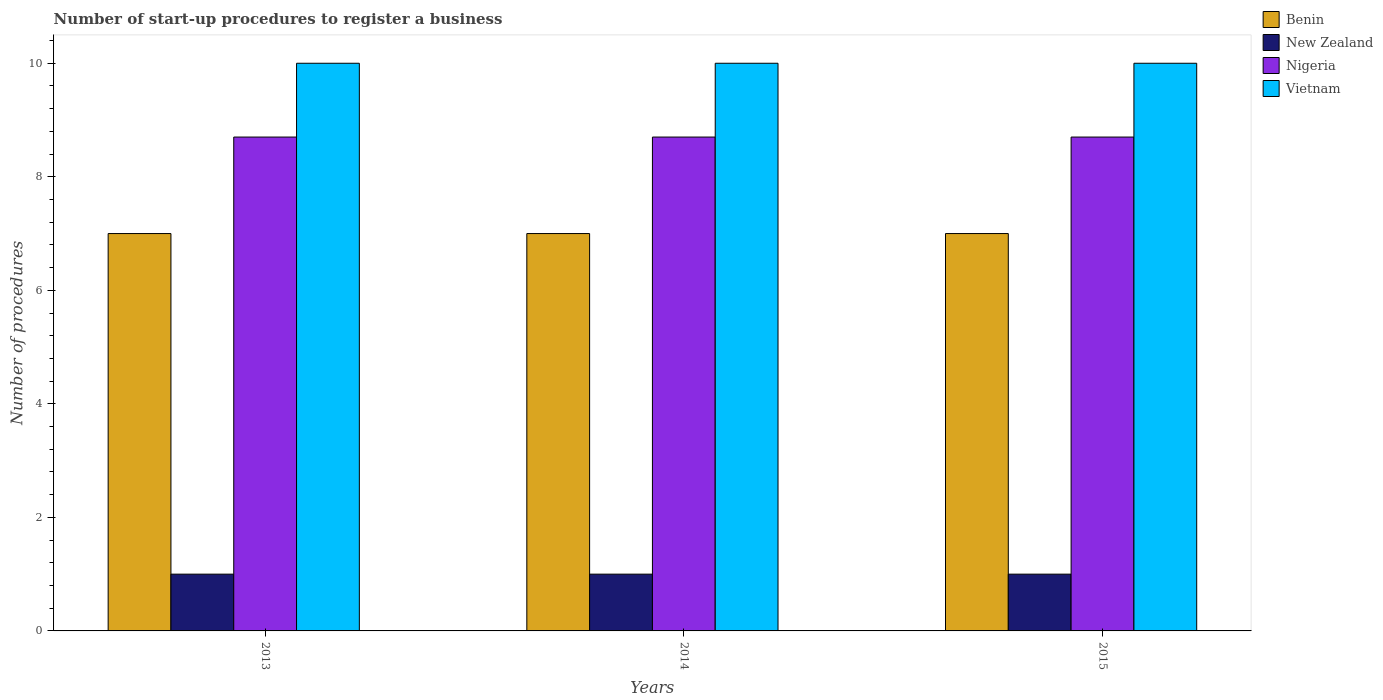How many different coloured bars are there?
Keep it short and to the point. 4. How many groups of bars are there?
Your response must be concise. 3. Are the number of bars per tick equal to the number of legend labels?
Make the answer very short. Yes. Are the number of bars on each tick of the X-axis equal?
Ensure brevity in your answer.  Yes. How many bars are there on the 1st tick from the right?
Keep it short and to the point. 4. What is the number of procedures required to register a business in Vietnam in 2015?
Your response must be concise. 10. Across all years, what is the maximum number of procedures required to register a business in Benin?
Offer a very short reply. 7. Across all years, what is the minimum number of procedures required to register a business in Nigeria?
Give a very brief answer. 8.7. What is the total number of procedures required to register a business in Benin in the graph?
Your response must be concise. 21. What is the difference between the number of procedures required to register a business in New Zealand in 2014 and the number of procedures required to register a business in Vietnam in 2013?
Offer a very short reply. -9. What is the average number of procedures required to register a business in Nigeria per year?
Make the answer very short. 8.7. In the year 2014, what is the difference between the number of procedures required to register a business in Vietnam and number of procedures required to register a business in Nigeria?
Offer a very short reply. 1.3. What is the ratio of the number of procedures required to register a business in Benin in 2013 to that in 2014?
Keep it short and to the point. 1. Is the number of procedures required to register a business in Benin in 2013 less than that in 2015?
Your answer should be very brief. No. Is the difference between the number of procedures required to register a business in Vietnam in 2013 and 2015 greater than the difference between the number of procedures required to register a business in Nigeria in 2013 and 2015?
Provide a succinct answer. No. What is the difference between the highest and the second highest number of procedures required to register a business in Benin?
Ensure brevity in your answer.  0. What is the difference between the highest and the lowest number of procedures required to register a business in New Zealand?
Keep it short and to the point. 0. Is it the case that in every year, the sum of the number of procedures required to register a business in New Zealand and number of procedures required to register a business in Nigeria is greater than the sum of number of procedures required to register a business in Benin and number of procedures required to register a business in Vietnam?
Make the answer very short. No. What does the 3rd bar from the left in 2013 represents?
Provide a succinct answer. Nigeria. What does the 3rd bar from the right in 2014 represents?
Keep it short and to the point. New Zealand. How many bars are there?
Provide a succinct answer. 12. How many years are there in the graph?
Your answer should be very brief. 3. What is the difference between two consecutive major ticks on the Y-axis?
Your answer should be very brief. 2. Are the values on the major ticks of Y-axis written in scientific E-notation?
Provide a succinct answer. No. Does the graph contain any zero values?
Offer a terse response. No. What is the title of the graph?
Offer a very short reply. Number of start-up procedures to register a business. Does "South Sudan" appear as one of the legend labels in the graph?
Provide a short and direct response. No. What is the label or title of the X-axis?
Make the answer very short. Years. What is the label or title of the Y-axis?
Give a very brief answer. Number of procedures. What is the Number of procedures in Benin in 2013?
Ensure brevity in your answer.  7. What is the Number of procedures of New Zealand in 2013?
Give a very brief answer. 1. What is the Number of procedures in Nigeria in 2013?
Your answer should be compact. 8.7. What is the Number of procedures in Nigeria in 2014?
Your answer should be compact. 8.7. What is the Number of procedures of Vietnam in 2014?
Your answer should be very brief. 10. What is the total Number of procedures of Benin in the graph?
Provide a short and direct response. 21. What is the total Number of procedures in Nigeria in the graph?
Make the answer very short. 26.1. What is the difference between the Number of procedures in Benin in 2013 and that in 2014?
Provide a short and direct response. 0. What is the difference between the Number of procedures of Benin in 2013 and that in 2015?
Provide a succinct answer. 0. What is the difference between the Number of procedures of New Zealand in 2013 and that in 2015?
Offer a very short reply. 0. What is the difference between the Number of procedures of Nigeria in 2013 and that in 2015?
Keep it short and to the point. 0. What is the difference between the Number of procedures in New Zealand in 2014 and that in 2015?
Give a very brief answer. 0. What is the difference between the Number of procedures of Nigeria in 2014 and that in 2015?
Give a very brief answer. 0. What is the difference between the Number of procedures in Vietnam in 2014 and that in 2015?
Your answer should be very brief. 0. What is the difference between the Number of procedures of Benin in 2013 and the Number of procedures of New Zealand in 2014?
Provide a succinct answer. 6. What is the difference between the Number of procedures of Benin in 2013 and the Number of procedures of Nigeria in 2014?
Your response must be concise. -1.7. What is the difference between the Number of procedures in Nigeria in 2013 and the Number of procedures in Vietnam in 2014?
Offer a very short reply. -1.3. What is the difference between the Number of procedures in Benin in 2013 and the Number of procedures in New Zealand in 2015?
Your answer should be compact. 6. What is the difference between the Number of procedures of Benin in 2013 and the Number of procedures of Nigeria in 2015?
Your answer should be compact. -1.7. What is the difference between the Number of procedures in Benin in 2013 and the Number of procedures in Vietnam in 2015?
Provide a short and direct response. -3. What is the difference between the Number of procedures of New Zealand in 2013 and the Number of procedures of Vietnam in 2015?
Offer a terse response. -9. What is the difference between the Number of procedures in Nigeria in 2013 and the Number of procedures in Vietnam in 2015?
Offer a very short reply. -1.3. What is the difference between the Number of procedures of Benin in 2014 and the Number of procedures of Nigeria in 2015?
Keep it short and to the point. -1.7. What is the difference between the Number of procedures of New Zealand in 2014 and the Number of procedures of Vietnam in 2015?
Keep it short and to the point. -9. In the year 2013, what is the difference between the Number of procedures of Benin and Number of procedures of New Zealand?
Your answer should be compact. 6. In the year 2013, what is the difference between the Number of procedures of Benin and Number of procedures of Vietnam?
Offer a terse response. -3. In the year 2013, what is the difference between the Number of procedures in New Zealand and Number of procedures in Nigeria?
Give a very brief answer. -7.7. In the year 2014, what is the difference between the Number of procedures in Benin and Number of procedures in Nigeria?
Provide a succinct answer. -1.7. In the year 2014, what is the difference between the Number of procedures in New Zealand and Number of procedures in Vietnam?
Make the answer very short. -9. In the year 2014, what is the difference between the Number of procedures in Nigeria and Number of procedures in Vietnam?
Offer a very short reply. -1.3. In the year 2015, what is the difference between the Number of procedures in Benin and Number of procedures in New Zealand?
Offer a very short reply. 6. In the year 2015, what is the difference between the Number of procedures in Benin and Number of procedures in Nigeria?
Make the answer very short. -1.7. In the year 2015, what is the difference between the Number of procedures in New Zealand and Number of procedures in Nigeria?
Ensure brevity in your answer.  -7.7. In the year 2015, what is the difference between the Number of procedures in New Zealand and Number of procedures in Vietnam?
Offer a very short reply. -9. What is the ratio of the Number of procedures of Nigeria in 2013 to that in 2014?
Offer a terse response. 1. What is the ratio of the Number of procedures of Vietnam in 2013 to that in 2014?
Keep it short and to the point. 1. What is the ratio of the Number of procedures of New Zealand in 2013 to that in 2015?
Ensure brevity in your answer.  1. What is the ratio of the Number of procedures in Nigeria in 2013 to that in 2015?
Keep it short and to the point. 1. What is the ratio of the Number of procedures of Benin in 2014 to that in 2015?
Your answer should be compact. 1. What is the ratio of the Number of procedures in New Zealand in 2014 to that in 2015?
Offer a very short reply. 1. What is the ratio of the Number of procedures of Nigeria in 2014 to that in 2015?
Provide a succinct answer. 1. What is the difference between the highest and the second highest Number of procedures of Benin?
Offer a terse response. 0. What is the difference between the highest and the second highest Number of procedures of New Zealand?
Give a very brief answer. 0. What is the difference between the highest and the second highest Number of procedures in Nigeria?
Offer a terse response. 0. What is the difference between the highest and the second highest Number of procedures of Vietnam?
Offer a terse response. 0. What is the difference between the highest and the lowest Number of procedures in Vietnam?
Ensure brevity in your answer.  0. 